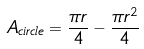<formula> <loc_0><loc_0><loc_500><loc_500>A _ { c i r c l e } = \frac { \pi r } { 4 } - \frac { \pi r ^ { 2 } } { 4 }</formula> 